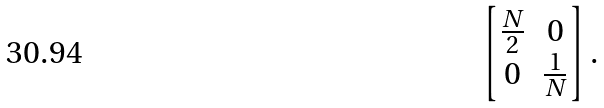<formula> <loc_0><loc_0><loc_500><loc_500>\begin{bmatrix} \frac { N } { 2 } & 0 \\ 0 & \frac { 1 } { N } \end{bmatrix} .</formula> 